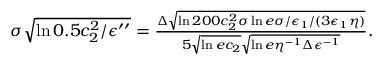<formula> <loc_0><loc_0><loc_500><loc_500>\begin{array} { r } { \sigma \sqrt { \ln { 0 . 5 c _ { 2 } ^ { 2 } / \epsilon ^ { \prime \prime } } } = \frac { \Delta \sqrt { \ln { 2 0 0 c _ { 2 } ^ { 2 } \sigma \ln { e \sigma / \epsilon _ { 1 } } / ( 3 \epsilon _ { 1 } \eta ) } } } { 5 \sqrt { \ln { e c _ { 2 } } } \sqrt { \ln { e \eta ^ { - 1 } \Delta \epsilon ^ { - 1 } } } } . } \end{array}</formula> 